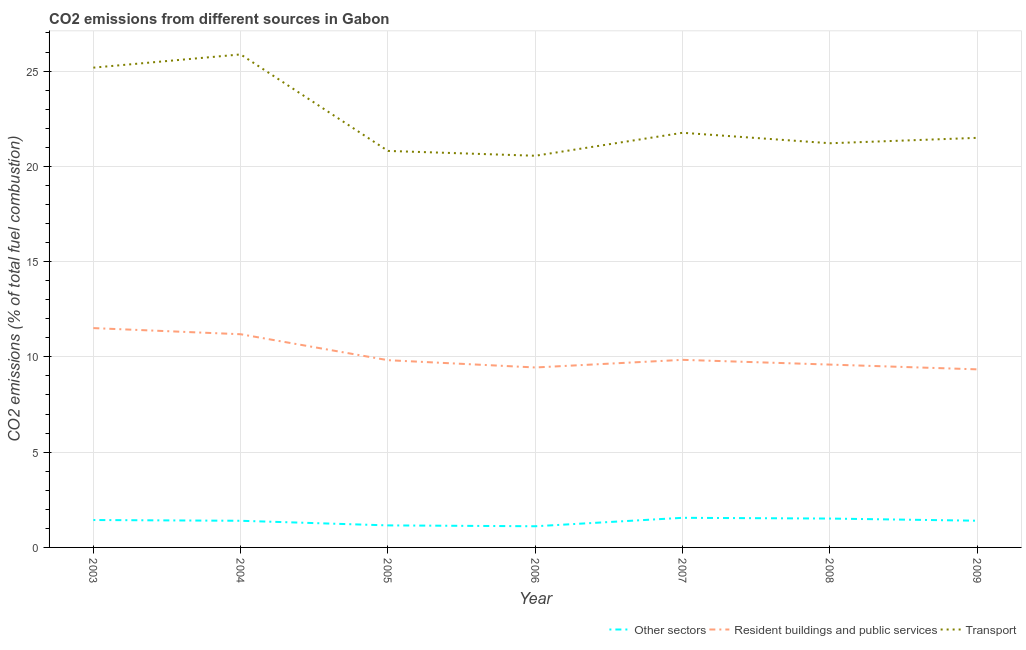How many different coloured lines are there?
Ensure brevity in your answer.  3. Does the line corresponding to percentage of co2 emissions from other sectors intersect with the line corresponding to percentage of co2 emissions from resident buildings and public services?
Keep it short and to the point. No. Is the number of lines equal to the number of legend labels?
Make the answer very short. Yes. What is the percentage of co2 emissions from resident buildings and public services in 2007?
Your answer should be compact. 9.84. Across all years, what is the maximum percentage of co2 emissions from transport?
Keep it short and to the point. 25.87. Across all years, what is the minimum percentage of co2 emissions from other sectors?
Provide a short and direct response. 1.11. In which year was the percentage of co2 emissions from other sectors maximum?
Offer a terse response. 2007. What is the total percentage of co2 emissions from resident buildings and public services in the graph?
Provide a succinct answer. 70.76. What is the difference between the percentage of co2 emissions from resident buildings and public services in 2008 and that in 2009?
Your response must be concise. 0.25. What is the difference between the percentage of co2 emissions from other sectors in 2007 and the percentage of co2 emissions from transport in 2008?
Offer a very short reply. -19.66. What is the average percentage of co2 emissions from other sectors per year?
Provide a succinct answer. 1.37. In the year 2005, what is the difference between the percentage of co2 emissions from transport and percentage of co2 emissions from resident buildings and public services?
Provide a short and direct response. 10.98. In how many years, is the percentage of co2 emissions from other sectors greater than 1 %?
Give a very brief answer. 7. What is the ratio of the percentage of co2 emissions from transport in 2005 to that in 2007?
Provide a short and direct response. 0.96. Is the difference between the percentage of co2 emissions from other sectors in 2004 and 2009 greater than the difference between the percentage of co2 emissions from transport in 2004 and 2009?
Your answer should be very brief. No. What is the difference between the highest and the second highest percentage of co2 emissions from resident buildings and public services?
Your answer should be very brief. 0.32. What is the difference between the highest and the lowest percentage of co2 emissions from resident buildings and public services?
Ensure brevity in your answer.  2.16. Is the sum of the percentage of co2 emissions from resident buildings and public services in 2003 and 2008 greater than the maximum percentage of co2 emissions from other sectors across all years?
Offer a terse response. Yes. Is the percentage of co2 emissions from resident buildings and public services strictly less than the percentage of co2 emissions from transport over the years?
Your answer should be compact. Yes. How many years are there in the graph?
Your answer should be very brief. 7. What is the difference between two consecutive major ticks on the Y-axis?
Provide a short and direct response. 5. Are the values on the major ticks of Y-axis written in scientific E-notation?
Your response must be concise. No. Does the graph contain grids?
Keep it short and to the point. Yes. Where does the legend appear in the graph?
Offer a very short reply. Bottom right. How many legend labels are there?
Ensure brevity in your answer.  3. How are the legend labels stacked?
Your answer should be very brief. Horizontal. What is the title of the graph?
Your answer should be very brief. CO2 emissions from different sources in Gabon. Does "Transport" appear as one of the legend labels in the graph?
Keep it short and to the point. Yes. What is the label or title of the Y-axis?
Ensure brevity in your answer.  CO2 emissions (% of total fuel combustion). What is the CO2 emissions (% of total fuel combustion) in Other sectors in 2003?
Give a very brief answer. 1.44. What is the CO2 emissions (% of total fuel combustion) in Resident buildings and public services in 2003?
Give a very brief answer. 11.51. What is the CO2 emissions (% of total fuel combustion) in Transport in 2003?
Provide a short and direct response. 25.18. What is the CO2 emissions (% of total fuel combustion) in Other sectors in 2004?
Give a very brief answer. 1.4. What is the CO2 emissions (% of total fuel combustion) of Resident buildings and public services in 2004?
Provide a short and direct response. 11.19. What is the CO2 emissions (% of total fuel combustion) in Transport in 2004?
Offer a very short reply. 25.87. What is the CO2 emissions (% of total fuel combustion) in Other sectors in 2005?
Provide a succinct answer. 1.16. What is the CO2 emissions (% of total fuel combustion) in Resident buildings and public services in 2005?
Your answer should be compact. 9.83. What is the CO2 emissions (% of total fuel combustion) of Transport in 2005?
Make the answer very short. 20.81. What is the CO2 emissions (% of total fuel combustion) in Other sectors in 2006?
Make the answer very short. 1.11. What is the CO2 emissions (% of total fuel combustion) in Resident buildings and public services in 2006?
Offer a terse response. 9.44. What is the CO2 emissions (% of total fuel combustion) in Transport in 2006?
Provide a short and direct response. 20.56. What is the CO2 emissions (% of total fuel combustion) in Other sectors in 2007?
Make the answer very short. 1.55. What is the CO2 emissions (% of total fuel combustion) of Resident buildings and public services in 2007?
Make the answer very short. 9.84. What is the CO2 emissions (% of total fuel combustion) in Transport in 2007?
Provide a short and direct response. 21.76. What is the CO2 emissions (% of total fuel combustion) of Other sectors in 2008?
Your response must be concise. 1.52. What is the CO2 emissions (% of total fuel combustion) in Resident buildings and public services in 2008?
Ensure brevity in your answer.  9.6. What is the CO2 emissions (% of total fuel combustion) in Transport in 2008?
Offer a very short reply. 21.21. What is the CO2 emissions (% of total fuel combustion) of Other sectors in 2009?
Provide a succinct answer. 1.4. What is the CO2 emissions (% of total fuel combustion) of Resident buildings and public services in 2009?
Provide a short and direct response. 9.35. What is the CO2 emissions (% of total fuel combustion) in Transport in 2009?
Ensure brevity in your answer.  21.5. Across all years, what is the maximum CO2 emissions (% of total fuel combustion) in Other sectors?
Your answer should be compact. 1.55. Across all years, what is the maximum CO2 emissions (% of total fuel combustion) of Resident buildings and public services?
Your response must be concise. 11.51. Across all years, what is the maximum CO2 emissions (% of total fuel combustion) in Transport?
Offer a terse response. 25.87. Across all years, what is the minimum CO2 emissions (% of total fuel combustion) in Other sectors?
Provide a succinct answer. 1.11. Across all years, what is the minimum CO2 emissions (% of total fuel combustion) of Resident buildings and public services?
Offer a terse response. 9.35. Across all years, what is the minimum CO2 emissions (% of total fuel combustion) in Transport?
Offer a terse response. 20.56. What is the total CO2 emissions (% of total fuel combustion) in Other sectors in the graph?
Offer a terse response. 9.58. What is the total CO2 emissions (% of total fuel combustion) in Resident buildings and public services in the graph?
Provide a short and direct response. 70.76. What is the total CO2 emissions (% of total fuel combustion) of Transport in the graph?
Your response must be concise. 156.89. What is the difference between the CO2 emissions (% of total fuel combustion) of Other sectors in 2003 and that in 2004?
Offer a very short reply. 0.04. What is the difference between the CO2 emissions (% of total fuel combustion) of Resident buildings and public services in 2003 and that in 2004?
Keep it short and to the point. 0.32. What is the difference between the CO2 emissions (% of total fuel combustion) of Transport in 2003 and that in 2004?
Your response must be concise. -0.69. What is the difference between the CO2 emissions (% of total fuel combustion) of Other sectors in 2003 and that in 2005?
Offer a terse response. 0.28. What is the difference between the CO2 emissions (% of total fuel combustion) in Resident buildings and public services in 2003 and that in 2005?
Give a very brief answer. 1.68. What is the difference between the CO2 emissions (% of total fuel combustion) of Transport in 2003 and that in 2005?
Provide a short and direct response. 4.37. What is the difference between the CO2 emissions (% of total fuel combustion) in Other sectors in 2003 and that in 2006?
Provide a short and direct response. 0.33. What is the difference between the CO2 emissions (% of total fuel combustion) of Resident buildings and public services in 2003 and that in 2006?
Keep it short and to the point. 2.07. What is the difference between the CO2 emissions (% of total fuel combustion) in Transport in 2003 and that in 2006?
Make the answer very short. 4.62. What is the difference between the CO2 emissions (% of total fuel combustion) in Other sectors in 2003 and that in 2007?
Your answer should be compact. -0.12. What is the difference between the CO2 emissions (% of total fuel combustion) in Resident buildings and public services in 2003 and that in 2007?
Give a very brief answer. 1.67. What is the difference between the CO2 emissions (% of total fuel combustion) in Transport in 2003 and that in 2007?
Offer a very short reply. 3.42. What is the difference between the CO2 emissions (% of total fuel combustion) of Other sectors in 2003 and that in 2008?
Ensure brevity in your answer.  -0.08. What is the difference between the CO2 emissions (% of total fuel combustion) of Resident buildings and public services in 2003 and that in 2008?
Keep it short and to the point. 1.91. What is the difference between the CO2 emissions (% of total fuel combustion) of Transport in 2003 and that in 2008?
Give a very brief answer. 3.97. What is the difference between the CO2 emissions (% of total fuel combustion) of Other sectors in 2003 and that in 2009?
Your response must be concise. 0.04. What is the difference between the CO2 emissions (% of total fuel combustion) in Resident buildings and public services in 2003 and that in 2009?
Your answer should be compact. 2.17. What is the difference between the CO2 emissions (% of total fuel combustion) of Transport in 2003 and that in 2009?
Provide a succinct answer. 3.68. What is the difference between the CO2 emissions (% of total fuel combustion) in Other sectors in 2004 and that in 2005?
Make the answer very short. 0.24. What is the difference between the CO2 emissions (% of total fuel combustion) in Resident buildings and public services in 2004 and that in 2005?
Provide a short and direct response. 1.36. What is the difference between the CO2 emissions (% of total fuel combustion) of Transport in 2004 and that in 2005?
Make the answer very short. 5.06. What is the difference between the CO2 emissions (% of total fuel combustion) in Other sectors in 2004 and that in 2006?
Provide a succinct answer. 0.29. What is the difference between the CO2 emissions (% of total fuel combustion) in Resident buildings and public services in 2004 and that in 2006?
Offer a terse response. 1.74. What is the difference between the CO2 emissions (% of total fuel combustion) in Transport in 2004 and that in 2006?
Provide a short and direct response. 5.32. What is the difference between the CO2 emissions (% of total fuel combustion) in Other sectors in 2004 and that in 2007?
Ensure brevity in your answer.  -0.16. What is the difference between the CO2 emissions (% of total fuel combustion) in Resident buildings and public services in 2004 and that in 2007?
Provide a succinct answer. 1.34. What is the difference between the CO2 emissions (% of total fuel combustion) of Transport in 2004 and that in 2007?
Give a very brief answer. 4.11. What is the difference between the CO2 emissions (% of total fuel combustion) in Other sectors in 2004 and that in 2008?
Your answer should be compact. -0.12. What is the difference between the CO2 emissions (% of total fuel combustion) in Resident buildings and public services in 2004 and that in 2008?
Give a very brief answer. 1.59. What is the difference between the CO2 emissions (% of total fuel combustion) in Transport in 2004 and that in 2008?
Make the answer very short. 4.66. What is the difference between the CO2 emissions (% of total fuel combustion) in Other sectors in 2004 and that in 2009?
Offer a very short reply. -0. What is the difference between the CO2 emissions (% of total fuel combustion) in Resident buildings and public services in 2004 and that in 2009?
Your response must be concise. 1.84. What is the difference between the CO2 emissions (% of total fuel combustion) in Transport in 2004 and that in 2009?
Your answer should be compact. 4.38. What is the difference between the CO2 emissions (% of total fuel combustion) of Other sectors in 2005 and that in 2006?
Provide a succinct answer. 0.04. What is the difference between the CO2 emissions (% of total fuel combustion) of Resident buildings and public services in 2005 and that in 2006?
Your response must be concise. 0.38. What is the difference between the CO2 emissions (% of total fuel combustion) of Transport in 2005 and that in 2006?
Offer a very short reply. 0.25. What is the difference between the CO2 emissions (% of total fuel combustion) in Other sectors in 2005 and that in 2007?
Your answer should be compact. -0.4. What is the difference between the CO2 emissions (% of total fuel combustion) in Resident buildings and public services in 2005 and that in 2007?
Offer a very short reply. -0.02. What is the difference between the CO2 emissions (% of total fuel combustion) in Transport in 2005 and that in 2007?
Your answer should be compact. -0.95. What is the difference between the CO2 emissions (% of total fuel combustion) in Other sectors in 2005 and that in 2008?
Ensure brevity in your answer.  -0.36. What is the difference between the CO2 emissions (% of total fuel combustion) of Resident buildings and public services in 2005 and that in 2008?
Your answer should be compact. 0.23. What is the difference between the CO2 emissions (% of total fuel combustion) in Transport in 2005 and that in 2008?
Your response must be concise. -0.4. What is the difference between the CO2 emissions (% of total fuel combustion) in Other sectors in 2005 and that in 2009?
Your answer should be compact. -0.25. What is the difference between the CO2 emissions (% of total fuel combustion) in Resident buildings and public services in 2005 and that in 2009?
Give a very brief answer. 0.48. What is the difference between the CO2 emissions (% of total fuel combustion) of Transport in 2005 and that in 2009?
Your answer should be very brief. -0.69. What is the difference between the CO2 emissions (% of total fuel combustion) in Other sectors in 2006 and that in 2007?
Provide a succinct answer. -0.44. What is the difference between the CO2 emissions (% of total fuel combustion) in Resident buildings and public services in 2006 and that in 2007?
Provide a succinct answer. -0.4. What is the difference between the CO2 emissions (% of total fuel combustion) of Transport in 2006 and that in 2007?
Make the answer very short. -1.21. What is the difference between the CO2 emissions (% of total fuel combustion) in Other sectors in 2006 and that in 2008?
Keep it short and to the point. -0.4. What is the difference between the CO2 emissions (% of total fuel combustion) of Resident buildings and public services in 2006 and that in 2008?
Your response must be concise. -0.15. What is the difference between the CO2 emissions (% of total fuel combustion) in Transport in 2006 and that in 2008?
Offer a very short reply. -0.66. What is the difference between the CO2 emissions (% of total fuel combustion) in Other sectors in 2006 and that in 2009?
Your answer should be very brief. -0.29. What is the difference between the CO2 emissions (% of total fuel combustion) in Resident buildings and public services in 2006 and that in 2009?
Your response must be concise. 0.1. What is the difference between the CO2 emissions (% of total fuel combustion) of Transport in 2006 and that in 2009?
Your response must be concise. -0.94. What is the difference between the CO2 emissions (% of total fuel combustion) of Other sectors in 2007 and that in 2008?
Your answer should be compact. 0.04. What is the difference between the CO2 emissions (% of total fuel combustion) of Resident buildings and public services in 2007 and that in 2008?
Provide a succinct answer. 0.25. What is the difference between the CO2 emissions (% of total fuel combustion) in Transport in 2007 and that in 2008?
Provide a short and direct response. 0.55. What is the difference between the CO2 emissions (% of total fuel combustion) of Other sectors in 2007 and that in 2009?
Provide a short and direct response. 0.15. What is the difference between the CO2 emissions (% of total fuel combustion) in Resident buildings and public services in 2007 and that in 2009?
Ensure brevity in your answer.  0.5. What is the difference between the CO2 emissions (% of total fuel combustion) in Transport in 2007 and that in 2009?
Keep it short and to the point. 0.27. What is the difference between the CO2 emissions (% of total fuel combustion) of Other sectors in 2008 and that in 2009?
Provide a short and direct response. 0.11. What is the difference between the CO2 emissions (% of total fuel combustion) in Resident buildings and public services in 2008 and that in 2009?
Keep it short and to the point. 0.25. What is the difference between the CO2 emissions (% of total fuel combustion) of Transport in 2008 and that in 2009?
Make the answer very short. -0.28. What is the difference between the CO2 emissions (% of total fuel combustion) of Other sectors in 2003 and the CO2 emissions (% of total fuel combustion) of Resident buildings and public services in 2004?
Give a very brief answer. -9.75. What is the difference between the CO2 emissions (% of total fuel combustion) in Other sectors in 2003 and the CO2 emissions (% of total fuel combustion) in Transport in 2004?
Provide a succinct answer. -24.44. What is the difference between the CO2 emissions (% of total fuel combustion) of Resident buildings and public services in 2003 and the CO2 emissions (% of total fuel combustion) of Transport in 2004?
Your response must be concise. -14.36. What is the difference between the CO2 emissions (% of total fuel combustion) in Other sectors in 2003 and the CO2 emissions (% of total fuel combustion) in Resident buildings and public services in 2005?
Your answer should be compact. -8.39. What is the difference between the CO2 emissions (% of total fuel combustion) of Other sectors in 2003 and the CO2 emissions (% of total fuel combustion) of Transport in 2005?
Offer a very short reply. -19.37. What is the difference between the CO2 emissions (% of total fuel combustion) in Resident buildings and public services in 2003 and the CO2 emissions (% of total fuel combustion) in Transport in 2005?
Offer a very short reply. -9.3. What is the difference between the CO2 emissions (% of total fuel combustion) of Other sectors in 2003 and the CO2 emissions (% of total fuel combustion) of Resident buildings and public services in 2006?
Your answer should be compact. -8.01. What is the difference between the CO2 emissions (% of total fuel combustion) of Other sectors in 2003 and the CO2 emissions (% of total fuel combustion) of Transport in 2006?
Offer a very short reply. -19.12. What is the difference between the CO2 emissions (% of total fuel combustion) in Resident buildings and public services in 2003 and the CO2 emissions (% of total fuel combustion) in Transport in 2006?
Provide a succinct answer. -9.04. What is the difference between the CO2 emissions (% of total fuel combustion) of Other sectors in 2003 and the CO2 emissions (% of total fuel combustion) of Resident buildings and public services in 2007?
Provide a short and direct response. -8.41. What is the difference between the CO2 emissions (% of total fuel combustion) of Other sectors in 2003 and the CO2 emissions (% of total fuel combustion) of Transport in 2007?
Offer a very short reply. -20.32. What is the difference between the CO2 emissions (% of total fuel combustion) of Resident buildings and public services in 2003 and the CO2 emissions (% of total fuel combustion) of Transport in 2007?
Offer a terse response. -10.25. What is the difference between the CO2 emissions (% of total fuel combustion) in Other sectors in 2003 and the CO2 emissions (% of total fuel combustion) in Resident buildings and public services in 2008?
Your answer should be compact. -8.16. What is the difference between the CO2 emissions (% of total fuel combustion) in Other sectors in 2003 and the CO2 emissions (% of total fuel combustion) in Transport in 2008?
Offer a very short reply. -19.77. What is the difference between the CO2 emissions (% of total fuel combustion) in Resident buildings and public services in 2003 and the CO2 emissions (% of total fuel combustion) in Transport in 2008?
Provide a succinct answer. -9.7. What is the difference between the CO2 emissions (% of total fuel combustion) of Other sectors in 2003 and the CO2 emissions (% of total fuel combustion) of Resident buildings and public services in 2009?
Your response must be concise. -7.91. What is the difference between the CO2 emissions (% of total fuel combustion) in Other sectors in 2003 and the CO2 emissions (% of total fuel combustion) in Transport in 2009?
Your answer should be very brief. -20.06. What is the difference between the CO2 emissions (% of total fuel combustion) in Resident buildings and public services in 2003 and the CO2 emissions (% of total fuel combustion) in Transport in 2009?
Offer a terse response. -9.98. What is the difference between the CO2 emissions (% of total fuel combustion) of Other sectors in 2004 and the CO2 emissions (% of total fuel combustion) of Resident buildings and public services in 2005?
Your answer should be compact. -8.43. What is the difference between the CO2 emissions (% of total fuel combustion) of Other sectors in 2004 and the CO2 emissions (% of total fuel combustion) of Transport in 2005?
Ensure brevity in your answer.  -19.41. What is the difference between the CO2 emissions (% of total fuel combustion) of Resident buildings and public services in 2004 and the CO2 emissions (% of total fuel combustion) of Transport in 2005?
Your answer should be compact. -9.62. What is the difference between the CO2 emissions (% of total fuel combustion) of Other sectors in 2004 and the CO2 emissions (% of total fuel combustion) of Resident buildings and public services in 2006?
Ensure brevity in your answer.  -8.05. What is the difference between the CO2 emissions (% of total fuel combustion) of Other sectors in 2004 and the CO2 emissions (% of total fuel combustion) of Transport in 2006?
Your answer should be very brief. -19.16. What is the difference between the CO2 emissions (% of total fuel combustion) in Resident buildings and public services in 2004 and the CO2 emissions (% of total fuel combustion) in Transport in 2006?
Your answer should be very brief. -9.37. What is the difference between the CO2 emissions (% of total fuel combustion) of Other sectors in 2004 and the CO2 emissions (% of total fuel combustion) of Resident buildings and public services in 2007?
Your answer should be very brief. -8.45. What is the difference between the CO2 emissions (% of total fuel combustion) of Other sectors in 2004 and the CO2 emissions (% of total fuel combustion) of Transport in 2007?
Ensure brevity in your answer.  -20.36. What is the difference between the CO2 emissions (% of total fuel combustion) in Resident buildings and public services in 2004 and the CO2 emissions (% of total fuel combustion) in Transport in 2007?
Give a very brief answer. -10.57. What is the difference between the CO2 emissions (% of total fuel combustion) of Other sectors in 2004 and the CO2 emissions (% of total fuel combustion) of Resident buildings and public services in 2008?
Provide a succinct answer. -8.2. What is the difference between the CO2 emissions (% of total fuel combustion) of Other sectors in 2004 and the CO2 emissions (% of total fuel combustion) of Transport in 2008?
Make the answer very short. -19.81. What is the difference between the CO2 emissions (% of total fuel combustion) in Resident buildings and public services in 2004 and the CO2 emissions (% of total fuel combustion) in Transport in 2008?
Your answer should be very brief. -10.02. What is the difference between the CO2 emissions (% of total fuel combustion) of Other sectors in 2004 and the CO2 emissions (% of total fuel combustion) of Resident buildings and public services in 2009?
Keep it short and to the point. -7.95. What is the difference between the CO2 emissions (% of total fuel combustion) in Other sectors in 2004 and the CO2 emissions (% of total fuel combustion) in Transport in 2009?
Provide a succinct answer. -20.1. What is the difference between the CO2 emissions (% of total fuel combustion) of Resident buildings and public services in 2004 and the CO2 emissions (% of total fuel combustion) of Transport in 2009?
Provide a short and direct response. -10.31. What is the difference between the CO2 emissions (% of total fuel combustion) in Other sectors in 2005 and the CO2 emissions (% of total fuel combustion) in Resident buildings and public services in 2006?
Your answer should be compact. -8.29. What is the difference between the CO2 emissions (% of total fuel combustion) of Other sectors in 2005 and the CO2 emissions (% of total fuel combustion) of Transport in 2006?
Ensure brevity in your answer.  -19.4. What is the difference between the CO2 emissions (% of total fuel combustion) in Resident buildings and public services in 2005 and the CO2 emissions (% of total fuel combustion) in Transport in 2006?
Give a very brief answer. -10.73. What is the difference between the CO2 emissions (% of total fuel combustion) in Other sectors in 2005 and the CO2 emissions (% of total fuel combustion) in Resident buildings and public services in 2007?
Your response must be concise. -8.69. What is the difference between the CO2 emissions (% of total fuel combustion) of Other sectors in 2005 and the CO2 emissions (% of total fuel combustion) of Transport in 2007?
Make the answer very short. -20.61. What is the difference between the CO2 emissions (% of total fuel combustion) in Resident buildings and public services in 2005 and the CO2 emissions (% of total fuel combustion) in Transport in 2007?
Make the answer very short. -11.94. What is the difference between the CO2 emissions (% of total fuel combustion) of Other sectors in 2005 and the CO2 emissions (% of total fuel combustion) of Resident buildings and public services in 2008?
Provide a succinct answer. -8.44. What is the difference between the CO2 emissions (% of total fuel combustion) in Other sectors in 2005 and the CO2 emissions (% of total fuel combustion) in Transport in 2008?
Provide a succinct answer. -20.06. What is the difference between the CO2 emissions (% of total fuel combustion) of Resident buildings and public services in 2005 and the CO2 emissions (% of total fuel combustion) of Transport in 2008?
Offer a terse response. -11.39. What is the difference between the CO2 emissions (% of total fuel combustion) of Other sectors in 2005 and the CO2 emissions (% of total fuel combustion) of Resident buildings and public services in 2009?
Offer a very short reply. -8.19. What is the difference between the CO2 emissions (% of total fuel combustion) of Other sectors in 2005 and the CO2 emissions (% of total fuel combustion) of Transport in 2009?
Give a very brief answer. -20.34. What is the difference between the CO2 emissions (% of total fuel combustion) of Resident buildings and public services in 2005 and the CO2 emissions (% of total fuel combustion) of Transport in 2009?
Ensure brevity in your answer.  -11.67. What is the difference between the CO2 emissions (% of total fuel combustion) of Other sectors in 2006 and the CO2 emissions (% of total fuel combustion) of Resident buildings and public services in 2007?
Your answer should be compact. -8.73. What is the difference between the CO2 emissions (% of total fuel combustion) of Other sectors in 2006 and the CO2 emissions (% of total fuel combustion) of Transport in 2007?
Keep it short and to the point. -20.65. What is the difference between the CO2 emissions (% of total fuel combustion) of Resident buildings and public services in 2006 and the CO2 emissions (% of total fuel combustion) of Transport in 2007?
Your answer should be compact. -12.32. What is the difference between the CO2 emissions (% of total fuel combustion) in Other sectors in 2006 and the CO2 emissions (% of total fuel combustion) in Resident buildings and public services in 2008?
Offer a terse response. -8.48. What is the difference between the CO2 emissions (% of total fuel combustion) of Other sectors in 2006 and the CO2 emissions (% of total fuel combustion) of Transport in 2008?
Your answer should be compact. -20.1. What is the difference between the CO2 emissions (% of total fuel combustion) of Resident buildings and public services in 2006 and the CO2 emissions (% of total fuel combustion) of Transport in 2008?
Offer a very short reply. -11.77. What is the difference between the CO2 emissions (% of total fuel combustion) in Other sectors in 2006 and the CO2 emissions (% of total fuel combustion) in Resident buildings and public services in 2009?
Ensure brevity in your answer.  -8.23. What is the difference between the CO2 emissions (% of total fuel combustion) of Other sectors in 2006 and the CO2 emissions (% of total fuel combustion) of Transport in 2009?
Offer a terse response. -20.38. What is the difference between the CO2 emissions (% of total fuel combustion) of Resident buildings and public services in 2006 and the CO2 emissions (% of total fuel combustion) of Transport in 2009?
Ensure brevity in your answer.  -12.05. What is the difference between the CO2 emissions (% of total fuel combustion) in Other sectors in 2007 and the CO2 emissions (% of total fuel combustion) in Resident buildings and public services in 2008?
Your answer should be very brief. -8.04. What is the difference between the CO2 emissions (% of total fuel combustion) of Other sectors in 2007 and the CO2 emissions (% of total fuel combustion) of Transport in 2008?
Ensure brevity in your answer.  -19.66. What is the difference between the CO2 emissions (% of total fuel combustion) in Resident buildings and public services in 2007 and the CO2 emissions (% of total fuel combustion) in Transport in 2008?
Ensure brevity in your answer.  -11.37. What is the difference between the CO2 emissions (% of total fuel combustion) of Other sectors in 2007 and the CO2 emissions (% of total fuel combustion) of Resident buildings and public services in 2009?
Ensure brevity in your answer.  -7.79. What is the difference between the CO2 emissions (% of total fuel combustion) in Other sectors in 2007 and the CO2 emissions (% of total fuel combustion) in Transport in 2009?
Offer a very short reply. -19.94. What is the difference between the CO2 emissions (% of total fuel combustion) in Resident buildings and public services in 2007 and the CO2 emissions (% of total fuel combustion) in Transport in 2009?
Ensure brevity in your answer.  -11.65. What is the difference between the CO2 emissions (% of total fuel combustion) in Other sectors in 2008 and the CO2 emissions (% of total fuel combustion) in Resident buildings and public services in 2009?
Give a very brief answer. -7.83. What is the difference between the CO2 emissions (% of total fuel combustion) of Other sectors in 2008 and the CO2 emissions (% of total fuel combustion) of Transport in 2009?
Make the answer very short. -19.98. What is the difference between the CO2 emissions (% of total fuel combustion) of Resident buildings and public services in 2008 and the CO2 emissions (% of total fuel combustion) of Transport in 2009?
Provide a short and direct response. -11.9. What is the average CO2 emissions (% of total fuel combustion) in Other sectors per year?
Offer a very short reply. 1.37. What is the average CO2 emissions (% of total fuel combustion) of Resident buildings and public services per year?
Make the answer very short. 10.11. What is the average CO2 emissions (% of total fuel combustion) in Transport per year?
Your answer should be compact. 22.41. In the year 2003, what is the difference between the CO2 emissions (% of total fuel combustion) in Other sectors and CO2 emissions (% of total fuel combustion) in Resident buildings and public services?
Make the answer very short. -10.07. In the year 2003, what is the difference between the CO2 emissions (% of total fuel combustion) in Other sectors and CO2 emissions (% of total fuel combustion) in Transport?
Give a very brief answer. -23.74. In the year 2003, what is the difference between the CO2 emissions (% of total fuel combustion) in Resident buildings and public services and CO2 emissions (% of total fuel combustion) in Transport?
Make the answer very short. -13.67. In the year 2004, what is the difference between the CO2 emissions (% of total fuel combustion) of Other sectors and CO2 emissions (% of total fuel combustion) of Resident buildings and public services?
Offer a very short reply. -9.79. In the year 2004, what is the difference between the CO2 emissions (% of total fuel combustion) in Other sectors and CO2 emissions (% of total fuel combustion) in Transport?
Provide a succinct answer. -24.48. In the year 2004, what is the difference between the CO2 emissions (% of total fuel combustion) of Resident buildings and public services and CO2 emissions (% of total fuel combustion) of Transport?
Give a very brief answer. -14.69. In the year 2005, what is the difference between the CO2 emissions (% of total fuel combustion) of Other sectors and CO2 emissions (% of total fuel combustion) of Resident buildings and public services?
Ensure brevity in your answer.  -8.67. In the year 2005, what is the difference between the CO2 emissions (% of total fuel combustion) of Other sectors and CO2 emissions (% of total fuel combustion) of Transport?
Offer a very short reply. -19.65. In the year 2005, what is the difference between the CO2 emissions (% of total fuel combustion) of Resident buildings and public services and CO2 emissions (% of total fuel combustion) of Transport?
Offer a terse response. -10.98. In the year 2006, what is the difference between the CO2 emissions (% of total fuel combustion) in Other sectors and CO2 emissions (% of total fuel combustion) in Resident buildings and public services?
Ensure brevity in your answer.  -8.33. In the year 2006, what is the difference between the CO2 emissions (% of total fuel combustion) of Other sectors and CO2 emissions (% of total fuel combustion) of Transport?
Provide a succinct answer. -19.44. In the year 2006, what is the difference between the CO2 emissions (% of total fuel combustion) of Resident buildings and public services and CO2 emissions (% of total fuel combustion) of Transport?
Ensure brevity in your answer.  -11.11. In the year 2007, what is the difference between the CO2 emissions (% of total fuel combustion) of Other sectors and CO2 emissions (% of total fuel combustion) of Resident buildings and public services?
Provide a short and direct response. -8.29. In the year 2007, what is the difference between the CO2 emissions (% of total fuel combustion) in Other sectors and CO2 emissions (% of total fuel combustion) in Transport?
Your answer should be compact. -20.21. In the year 2007, what is the difference between the CO2 emissions (% of total fuel combustion) in Resident buildings and public services and CO2 emissions (% of total fuel combustion) in Transport?
Ensure brevity in your answer.  -11.92. In the year 2008, what is the difference between the CO2 emissions (% of total fuel combustion) in Other sectors and CO2 emissions (% of total fuel combustion) in Resident buildings and public services?
Offer a terse response. -8.08. In the year 2008, what is the difference between the CO2 emissions (% of total fuel combustion) of Other sectors and CO2 emissions (% of total fuel combustion) of Transport?
Your response must be concise. -19.7. In the year 2008, what is the difference between the CO2 emissions (% of total fuel combustion) in Resident buildings and public services and CO2 emissions (% of total fuel combustion) in Transport?
Offer a terse response. -11.62. In the year 2009, what is the difference between the CO2 emissions (% of total fuel combustion) in Other sectors and CO2 emissions (% of total fuel combustion) in Resident buildings and public services?
Your answer should be very brief. -7.94. In the year 2009, what is the difference between the CO2 emissions (% of total fuel combustion) in Other sectors and CO2 emissions (% of total fuel combustion) in Transport?
Offer a very short reply. -20.09. In the year 2009, what is the difference between the CO2 emissions (% of total fuel combustion) of Resident buildings and public services and CO2 emissions (% of total fuel combustion) of Transport?
Ensure brevity in your answer.  -12.15. What is the ratio of the CO2 emissions (% of total fuel combustion) in Other sectors in 2003 to that in 2004?
Your answer should be compact. 1.03. What is the ratio of the CO2 emissions (% of total fuel combustion) of Resident buildings and public services in 2003 to that in 2004?
Your answer should be compact. 1.03. What is the ratio of the CO2 emissions (% of total fuel combustion) of Transport in 2003 to that in 2004?
Provide a short and direct response. 0.97. What is the ratio of the CO2 emissions (% of total fuel combustion) in Other sectors in 2003 to that in 2005?
Offer a very short reply. 1.24. What is the ratio of the CO2 emissions (% of total fuel combustion) of Resident buildings and public services in 2003 to that in 2005?
Your answer should be very brief. 1.17. What is the ratio of the CO2 emissions (% of total fuel combustion) in Transport in 2003 to that in 2005?
Give a very brief answer. 1.21. What is the ratio of the CO2 emissions (% of total fuel combustion) of Other sectors in 2003 to that in 2006?
Make the answer very short. 1.29. What is the ratio of the CO2 emissions (% of total fuel combustion) in Resident buildings and public services in 2003 to that in 2006?
Offer a terse response. 1.22. What is the ratio of the CO2 emissions (% of total fuel combustion) in Transport in 2003 to that in 2006?
Keep it short and to the point. 1.23. What is the ratio of the CO2 emissions (% of total fuel combustion) in Other sectors in 2003 to that in 2007?
Ensure brevity in your answer.  0.93. What is the ratio of the CO2 emissions (% of total fuel combustion) of Resident buildings and public services in 2003 to that in 2007?
Your answer should be compact. 1.17. What is the ratio of the CO2 emissions (% of total fuel combustion) of Transport in 2003 to that in 2007?
Keep it short and to the point. 1.16. What is the ratio of the CO2 emissions (% of total fuel combustion) in Other sectors in 2003 to that in 2008?
Offer a terse response. 0.95. What is the ratio of the CO2 emissions (% of total fuel combustion) of Resident buildings and public services in 2003 to that in 2008?
Make the answer very short. 1.2. What is the ratio of the CO2 emissions (% of total fuel combustion) in Transport in 2003 to that in 2008?
Offer a very short reply. 1.19. What is the ratio of the CO2 emissions (% of total fuel combustion) in Other sectors in 2003 to that in 2009?
Offer a terse response. 1.03. What is the ratio of the CO2 emissions (% of total fuel combustion) of Resident buildings and public services in 2003 to that in 2009?
Your answer should be very brief. 1.23. What is the ratio of the CO2 emissions (% of total fuel combustion) in Transport in 2003 to that in 2009?
Give a very brief answer. 1.17. What is the ratio of the CO2 emissions (% of total fuel combustion) of Other sectors in 2004 to that in 2005?
Make the answer very short. 1.21. What is the ratio of the CO2 emissions (% of total fuel combustion) of Resident buildings and public services in 2004 to that in 2005?
Offer a very short reply. 1.14. What is the ratio of the CO2 emissions (% of total fuel combustion) in Transport in 2004 to that in 2005?
Your response must be concise. 1.24. What is the ratio of the CO2 emissions (% of total fuel combustion) in Other sectors in 2004 to that in 2006?
Provide a short and direct response. 1.26. What is the ratio of the CO2 emissions (% of total fuel combustion) of Resident buildings and public services in 2004 to that in 2006?
Offer a very short reply. 1.18. What is the ratio of the CO2 emissions (% of total fuel combustion) in Transport in 2004 to that in 2006?
Make the answer very short. 1.26. What is the ratio of the CO2 emissions (% of total fuel combustion) of Other sectors in 2004 to that in 2007?
Provide a succinct answer. 0.9. What is the ratio of the CO2 emissions (% of total fuel combustion) of Resident buildings and public services in 2004 to that in 2007?
Your answer should be very brief. 1.14. What is the ratio of the CO2 emissions (% of total fuel combustion) in Transport in 2004 to that in 2007?
Your answer should be very brief. 1.19. What is the ratio of the CO2 emissions (% of total fuel combustion) in Other sectors in 2004 to that in 2008?
Your answer should be compact. 0.92. What is the ratio of the CO2 emissions (% of total fuel combustion) in Resident buildings and public services in 2004 to that in 2008?
Provide a succinct answer. 1.17. What is the ratio of the CO2 emissions (% of total fuel combustion) in Transport in 2004 to that in 2008?
Ensure brevity in your answer.  1.22. What is the ratio of the CO2 emissions (% of total fuel combustion) in Other sectors in 2004 to that in 2009?
Provide a short and direct response. 1. What is the ratio of the CO2 emissions (% of total fuel combustion) of Resident buildings and public services in 2004 to that in 2009?
Your answer should be very brief. 1.2. What is the ratio of the CO2 emissions (% of total fuel combustion) in Transport in 2004 to that in 2009?
Your answer should be very brief. 1.2. What is the ratio of the CO2 emissions (% of total fuel combustion) of Other sectors in 2005 to that in 2006?
Your response must be concise. 1.04. What is the ratio of the CO2 emissions (% of total fuel combustion) of Resident buildings and public services in 2005 to that in 2006?
Provide a succinct answer. 1.04. What is the ratio of the CO2 emissions (% of total fuel combustion) in Transport in 2005 to that in 2006?
Provide a succinct answer. 1.01. What is the ratio of the CO2 emissions (% of total fuel combustion) in Other sectors in 2005 to that in 2007?
Offer a very short reply. 0.74. What is the ratio of the CO2 emissions (% of total fuel combustion) in Resident buildings and public services in 2005 to that in 2007?
Make the answer very short. 1. What is the ratio of the CO2 emissions (% of total fuel combustion) in Transport in 2005 to that in 2007?
Keep it short and to the point. 0.96. What is the ratio of the CO2 emissions (% of total fuel combustion) of Other sectors in 2005 to that in 2008?
Make the answer very short. 0.76. What is the ratio of the CO2 emissions (% of total fuel combustion) of Resident buildings and public services in 2005 to that in 2008?
Provide a short and direct response. 1.02. What is the ratio of the CO2 emissions (% of total fuel combustion) in Other sectors in 2005 to that in 2009?
Provide a short and direct response. 0.82. What is the ratio of the CO2 emissions (% of total fuel combustion) of Resident buildings and public services in 2005 to that in 2009?
Offer a very short reply. 1.05. What is the ratio of the CO2 emissions (% of total fuel combustion) in Transport in 2005 to that in 2009?
Keep it short and to the point. 0.97. What is the ratio of the CO2 emissions (% of total fuel combustion) in Other sectors in 2006 to that in 2007?
Give a very brief answer. 0.71. What is the ratio of the CO2 emissions (% of total fuel combustion) of Resident buildings and public services in 2006 to that in 2007?
Offer a very short reply. 0.96. What is the ratio of the CO2 emissions (% of total fuel combustion) of Transport in 2006 to that in 2007?
Make the answer very short. 0.94. What is the ratio of the CO2 emissions (% of total fuel combustion) of Other sectors in 2006 to that in 2008?
Your response must be concise. 0.73. What is the ratio of the CO2 emissions (% of total fuel combustion) of Resident buildings and public services in 2006 to that in 2008?
Make the answer very short. 0.98. What is the ratio of the CO2 emissions (% of total fuel combustion) of Other sectors in 2006 to that in 2009?
Your response must be concise. 0.79. What is the ratio of the CO2 emissions (% of total fuel combustion) in Resident buildings and public services in 2006 to that in 2009?
Your response must be concise. 1.01. What is the ratio of the CO2 emissions (% of total fuel combustion) in Transport in 2006 to that in 2009?
Offer a very short reply. 0.96. What is the ratio of the CO2 emissions (% of total fuel combustion) of Other sectors in 2007 to that in 2008?
Provide a succinct answer. 1.03. What is the ratio of the CO2 emissions (% of total fuel combustion) in Resident buildings and public services in 2007 to that in 2008?
Provide a succinct answer. 1.03. What is the ratio of the CO2 emissions (% of total fuel combustion) of Transport in 2007 to that in 2008?
Provide a succinct answer. 1.03. What is the ratio of the CO2 emissions (% of total fuel combustion) of Other sectors in 2007 to that in 2009?
Your answer should be very brief. 1.11. What is the ratio of the CO2 emissions (% of total fuel combustion) in Resident buildings and public services in 2007 to that in 2009?
Ensure brevity in your answer.  1.05. What is the ratio of the CO2 emissions (% of total fuel combustion) in Transport in 2007 to that in 2009?
Your response must be concise. 1.01. What is the ratio of the CO2 emissions (% of total fuel combustion) in Other sectors in 2008 to that in 2009?
Provide a short and direct response. 1.08. What is the ratio of the CO2 emissions (% of total fuel combustion) of Resident buildings and public services in 2008 to that in 2009?
Offer a terse response. 1.03. What is the difference between the highest and the second highest CO2 emissions (% of total fuel combustion) in Other sectors?
Make the answer very short. 0.04. What is the difference between the highest and the second highest CO2 emissions (% of total fuel combustion) in Resident buildings and public services?
Make the answer very short. 0.32. What is the difference between the highest and the second highest CO2 emissions (% of total fuel combustion) in Transport?
Offer a terse response. 0.69. What is the difference between the highest and the lowest CO2 emissions (% of total fuel combustion) of Other sectors?
Give a very brief answer. 0.44. What is the difference between the highest and the lowest CO2 emissions (% of total fuel combustion) of Resident buildings and public services?
Your answer should be very brief. 2.17. What is the difference between the highest and the lowest CO2 emissions (% of total fuel combustion) in Transport?
Your answer should be very brief. 5.32. 